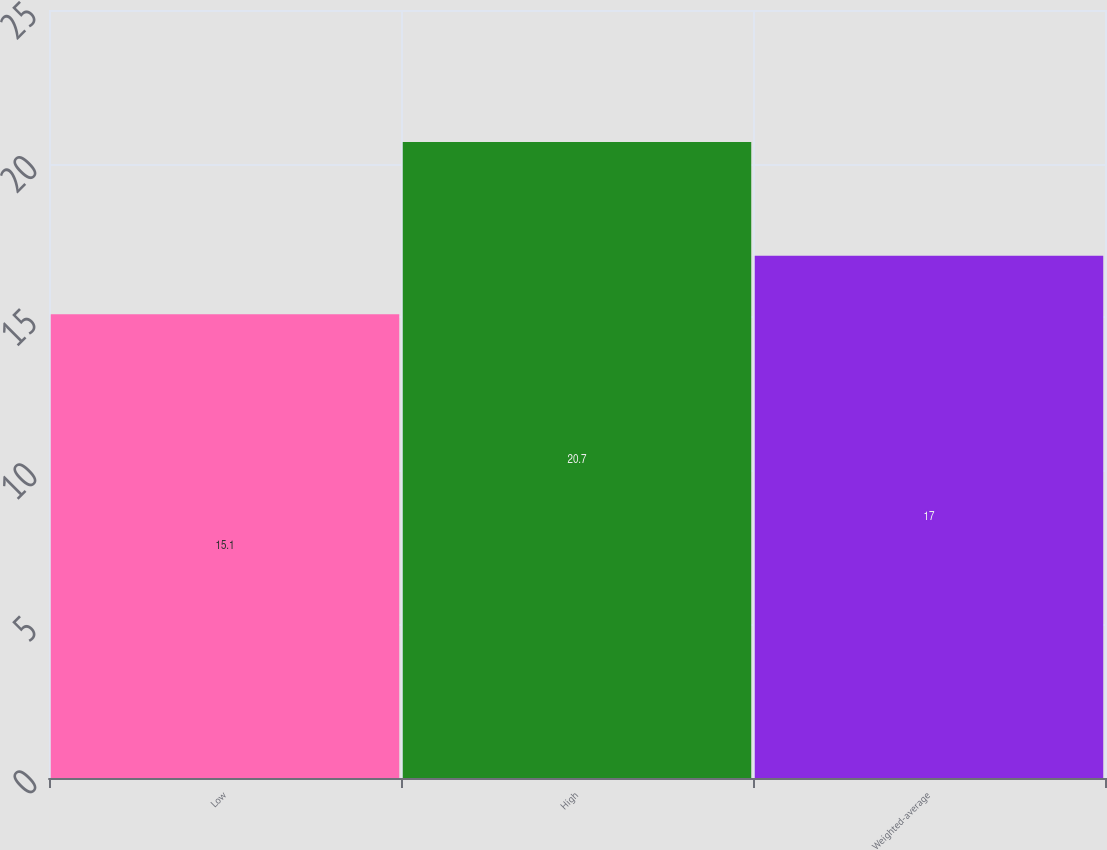Convert chart. <chart><loc_0><loc_0><loc_500><loc_500><bar_chart><fcel>Low<fcel>High<fcel>Weighted-average<nl><fcel>15.1<fcel>20.7<fcel>17<nl></chart> 